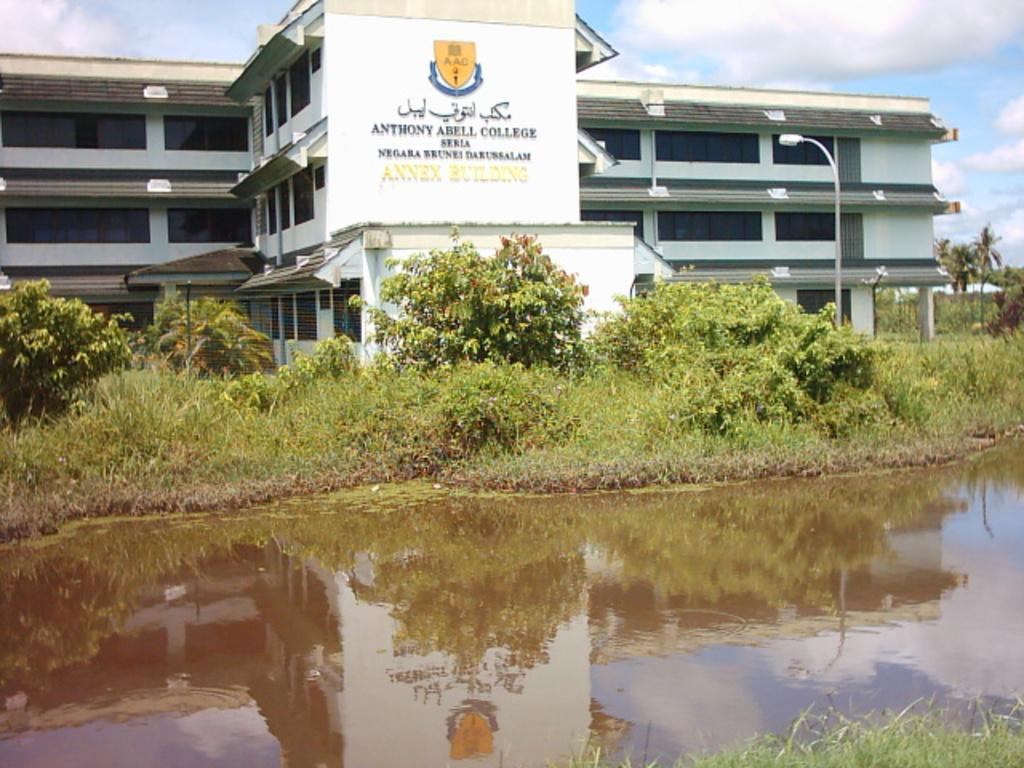<image>
Give a short and clear explanation of the subsequent image. An outside appearance of Anthony Abell College in a sunny day. 